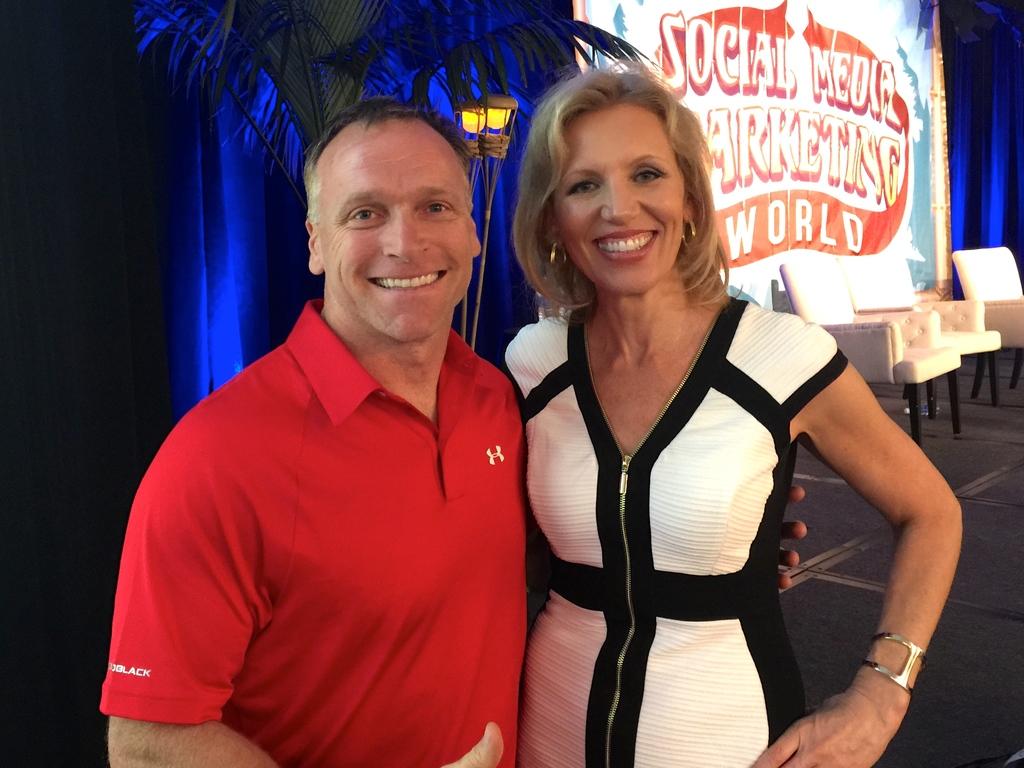What event is this?
Your answer should be very brief. Social media marketing world. What is on the mans sleeve?
Offer a very short reply. Black. 